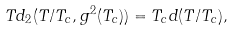<formula> <loc_0><loc_0><loc_500><loc_500>T d _ { 2 } ( T / T _ { c } , g ^ { 2 } ( T _ { c } ) ) = T _ { c } d ( T / T _ { c } ) ,</formula> 